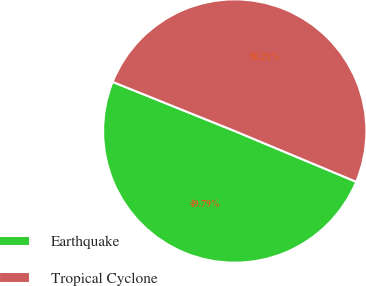Convert chart to OTSL. <chart><loc_0><loc_0><loc_500><loc_500><pie_chart><fcel>Earthquake<fcel>Tropical Cyclone<nl><fcel>49.79%<fcel>50.21%<nl></chart> 